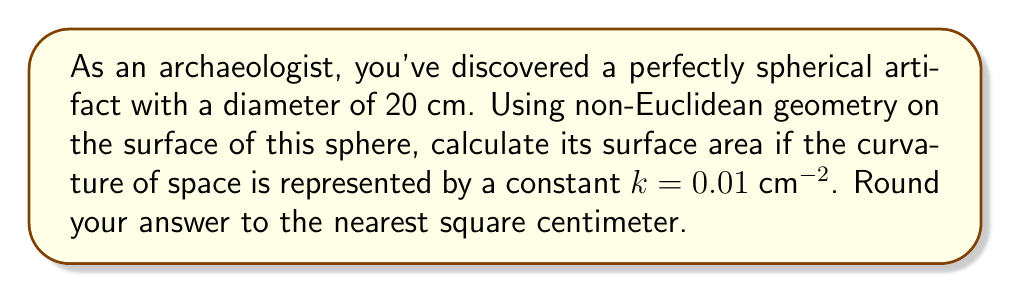Solve this math problem. To solve this problem, we'll use concepts from non-Euclidean geometry, specifically spherical geometry. The steps are as follows:

1) In non-Euclidean geometry, the surface area of a sphere is given by the formula:

   $$ A = \frac{4\pi}{k} \sin^2(\sqrt{k}\frac{r}{2}) $$

   Where $k$ is the curvature and $r$ is the radius of the sphere.

2) We're given the diameter of 20 cm, so the radius $r = 10$ cm.

3) The curvature $k = 0.01$ $cm^{-2}$.

4) Let's substitute these values into our formula:

   $$ A = \frac{4\pi}{0.01} \sin^2(\sqrt{0.01}\frac{10}{2}) $$

5) Simplify inside the sine function:

   $$ A = 400\pi \sin^2(0.05\sqrt{10}) $$

6) Calculate the value inside the sine:

   $$ A = 400\pi \sin^2(0.158113883) $$

7) Calculate the sine:

   $$ A = 400\pi (0.024894368)^2 $$

8) Complete the calculation:

   $$ A = 400\pi (0.000619729) = 0.7791844796 \pi $$

9) Multiply by $\pi$:

   $$ A = 2.447017991 $$

10) Rounding to the nearest square centimeter:

    $$ A \approx 2 \text{ cm}^2 $$
Answer: 2 $\text{cm}^2$ 